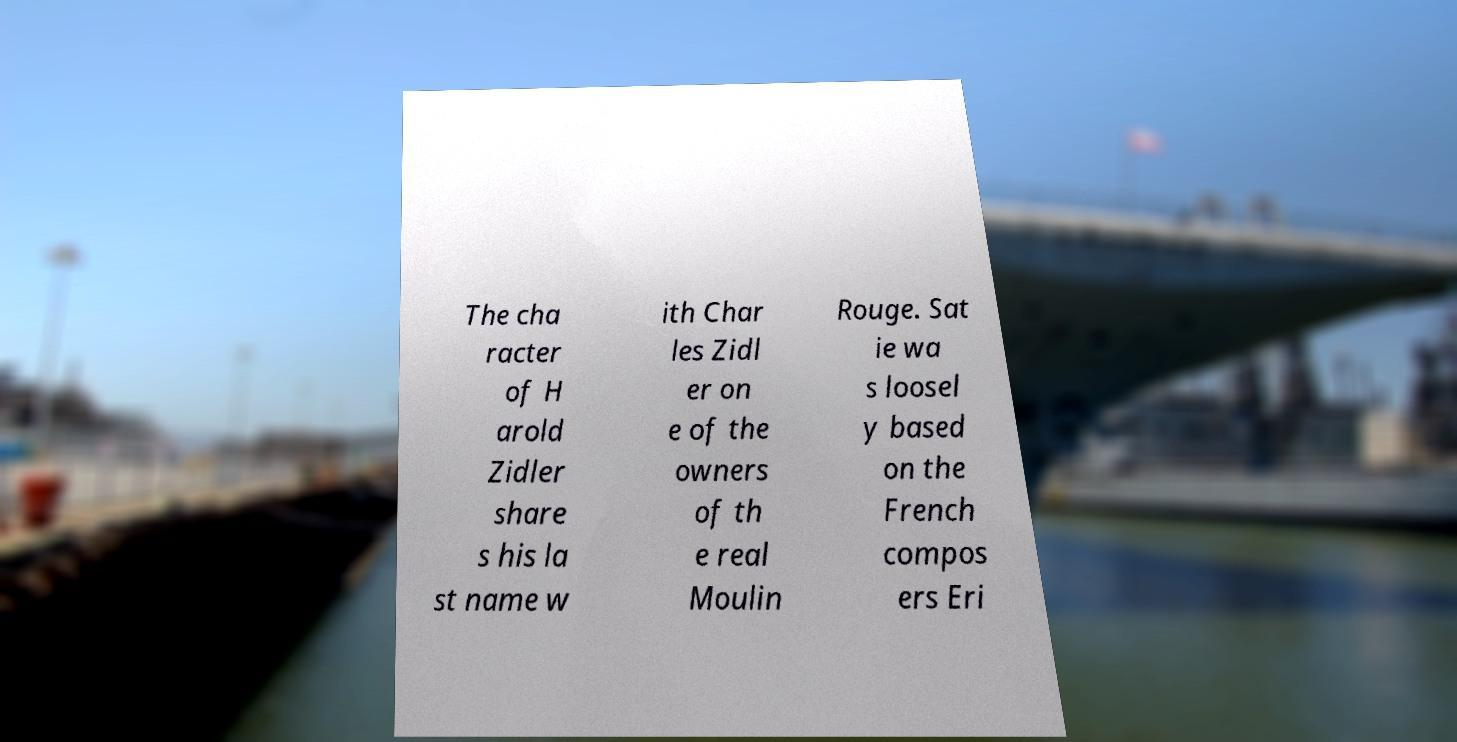Please identify and transcribe the text found in this image. The cha racter of H arold Zidler share s his la st name w ith Char les Zidl er on e of the owners of th e real Moulin Rouge. Sat ie wa s loosel y based on the French compos ers Eri 